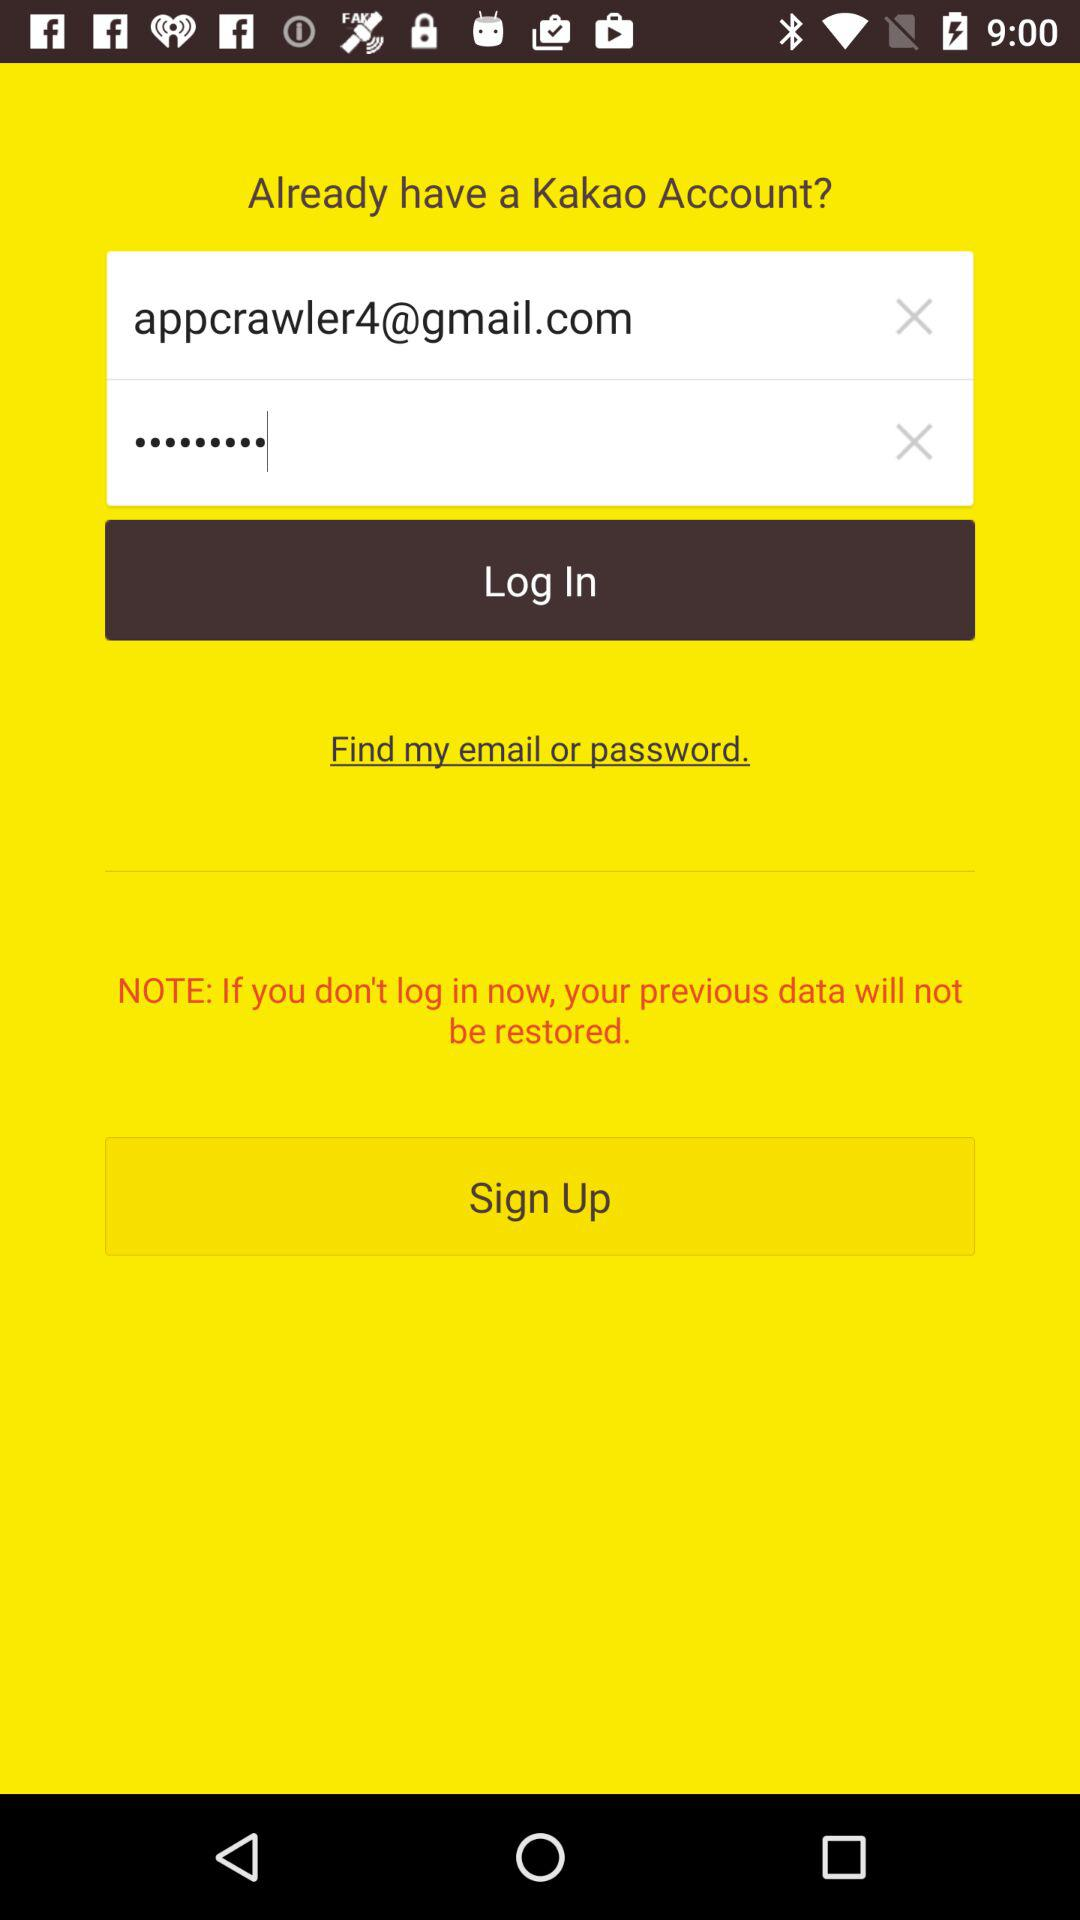What is an email address? An email address is appcrawler4@gmail.com. 